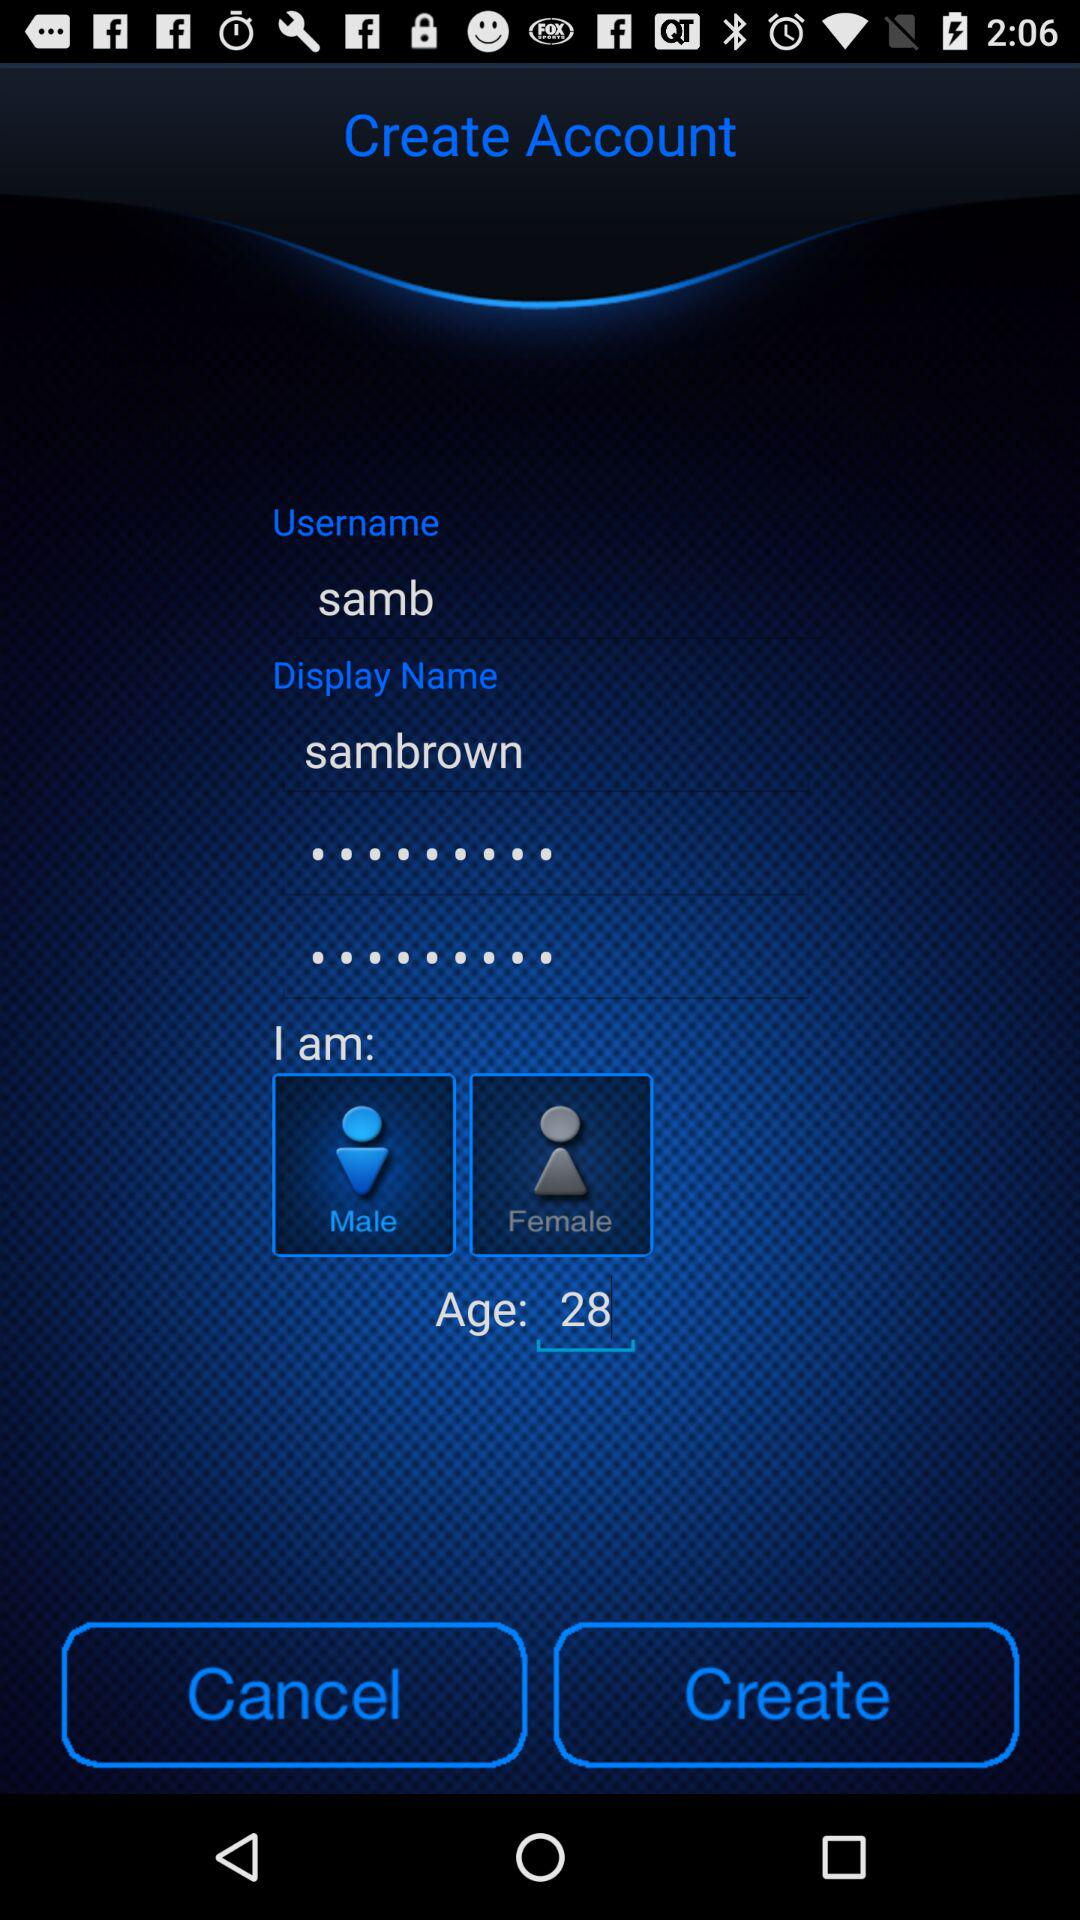What is the age of samb? The age of samb is 28. 